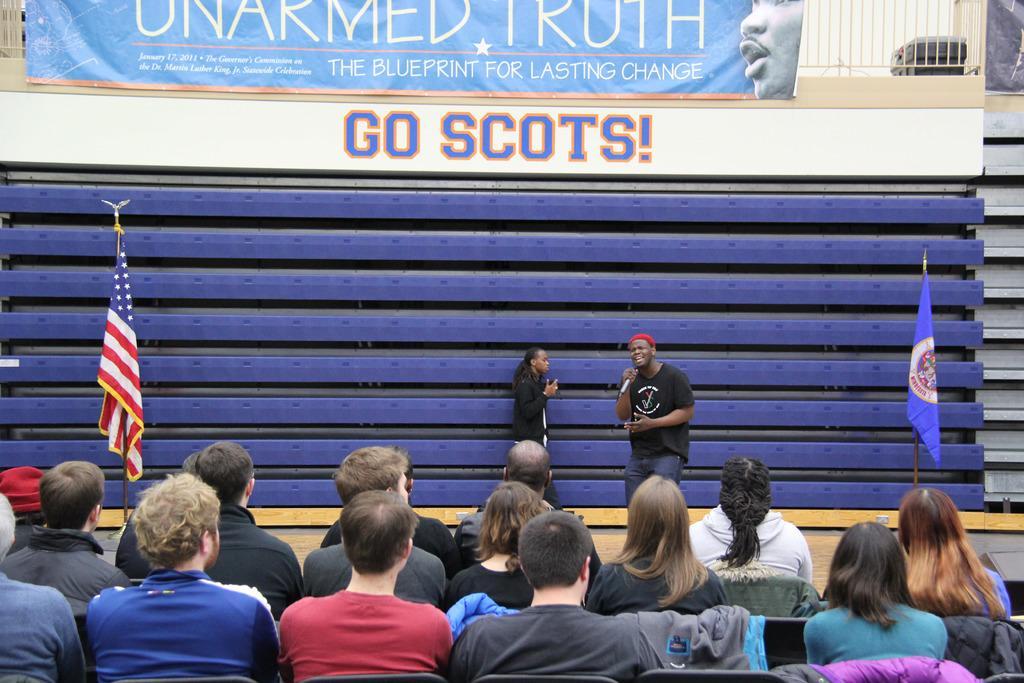How would you summarize this image in a sentence or two? In this image there are two persons, one person holding a mike visible in front of shatter, on the shatter there is a banner and there are two flags visible in front of shatter, at the bottom there are few people sitting on chair, on the banner there is a text and person image and symbol visible. 